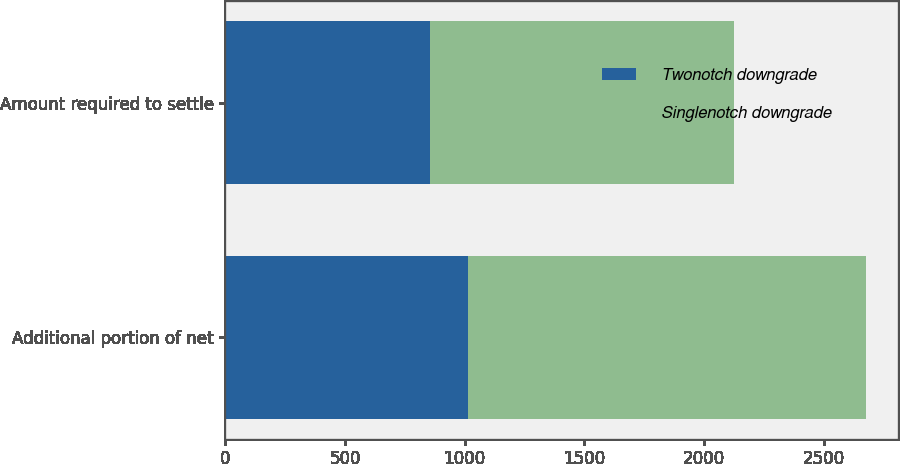Convert chart to OTSL. <chart><loc_0><loc_0><loc_500><loc_500><stacked_bar_chart><ecel><fcel>Additional portion of net<fcel>Amount required to settle<nl><fcel>Twonotch downgrade<fcel>1012<fcel>857<nl><fcel>Singlenotch downgrade<fcel>1664<fcel>1270<nl></chart> 